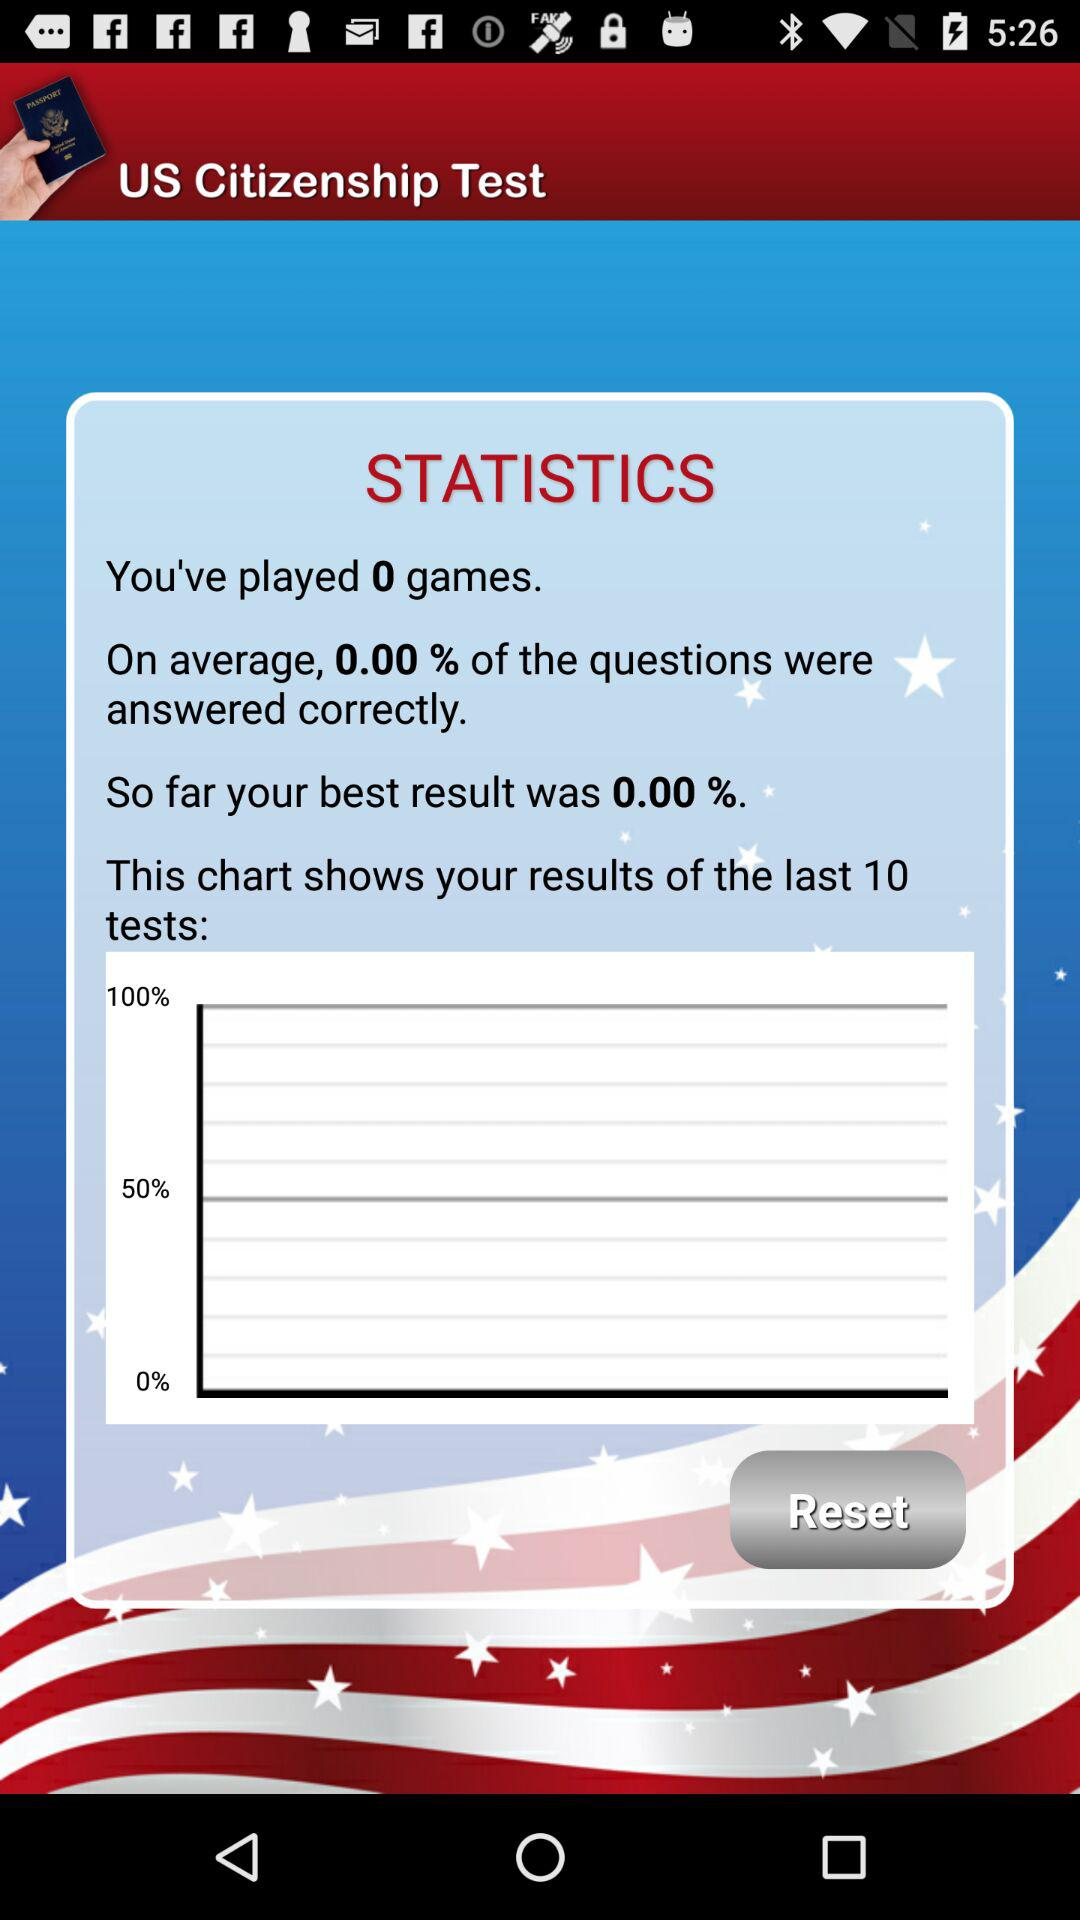What was my best result? So far, your best result was 0.00%. 